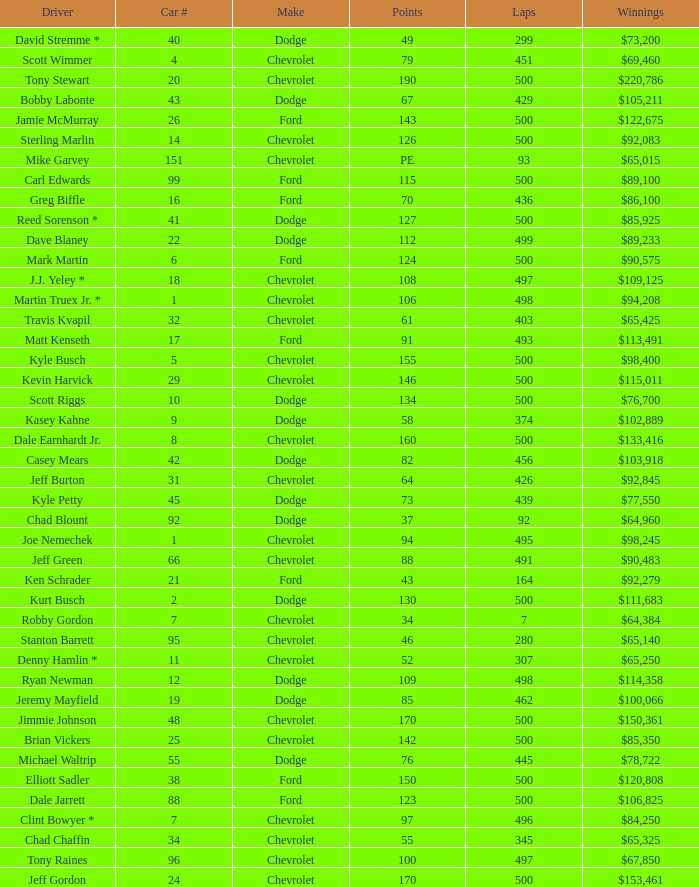What make of car did Brian Vickers drive? Chevrolet. 